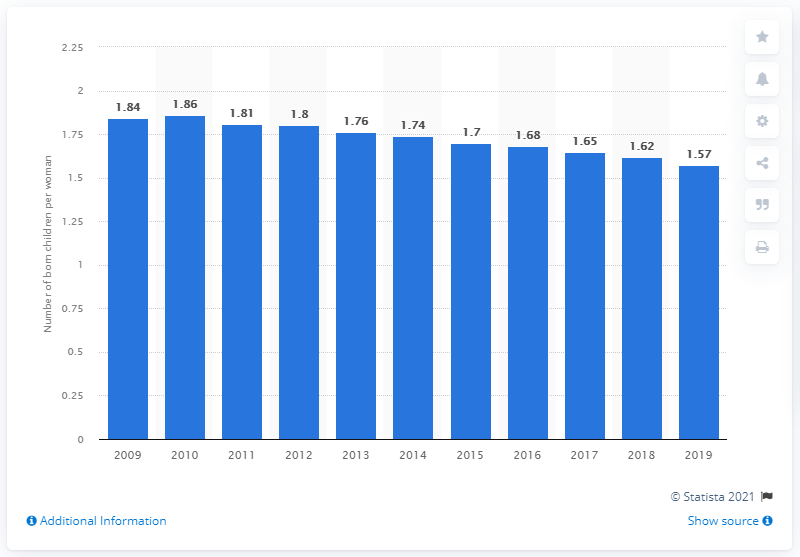Point out several critical features in this image. In 2019, the fertility rate in Belgium was 1.57 children per woman. 